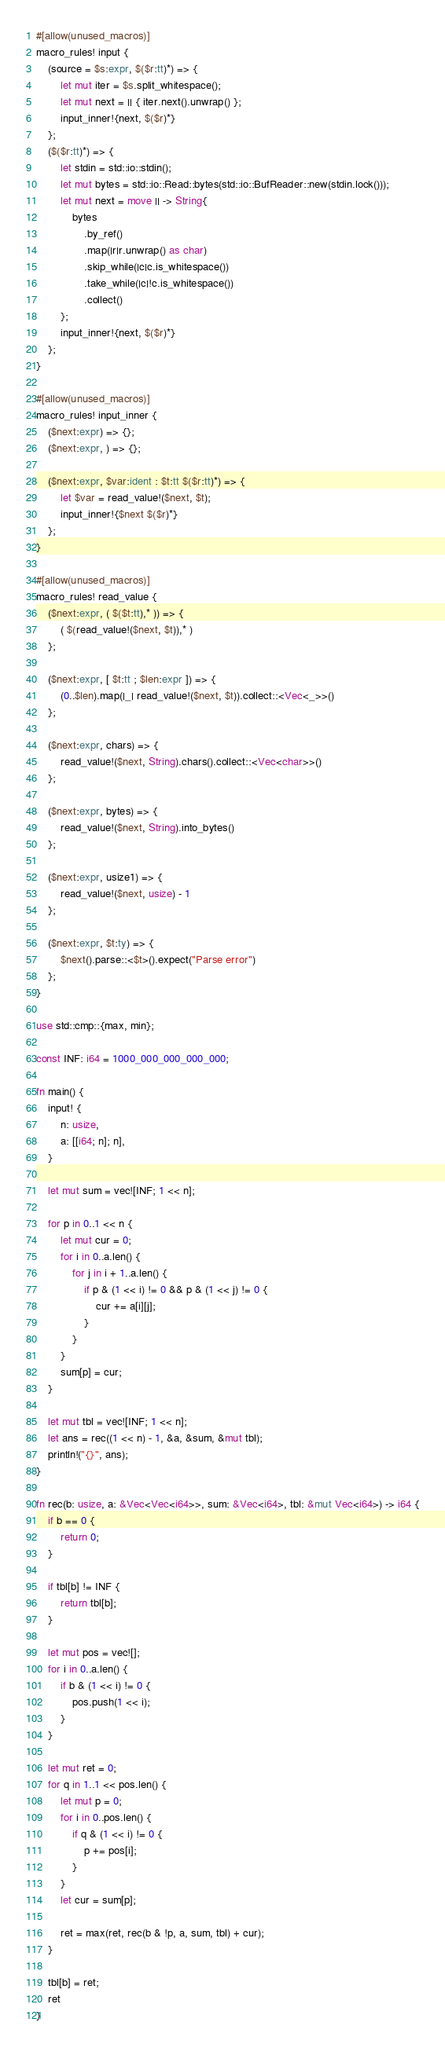<code> <loc_0><loc_0><loc_500><loc_500><_Rust_>#[allow(unused_macros)]
macro_rules! input {
    (source = $s:expr, $($r:tt)*) => {
        let mut iter = $s.split_whitespace();
        let mut next = || { iter.next().unwrap() };
        input_inner!{next, $($r)*}
    };
    ($($r:tt)*) => {
        let stdin = std::io::stdin();
        let mut bytes = std::io::Read::bytes(std::io::BufReader::new(stdin.lock()));
        let mut next = move || -> String{
            bytes
                .by_ref()
                .map(|r|r.unwrap() as char)
                .skip_while(|c|c.is_whitespace())
                .take_while(|c|!c.is_whitespace())
                .collect()
        };
        input_inner!{next, $($r)*}
    };
}

#[allow(unused_macros)]
macro_rules! input_inner {
    ($next:expr) => {};
    ($next:expr, ) => {};

    ($next:expr, $var:ident : $t:tt $($r:tt)*) => {
        let $var = read_value!($next, $t);
        input_inner!{$next $($r)*}
    };
}

#[allow(unused_macros)]
macro_rules! read_value {
    ($next:expr, ( $($t:tt),* )) => {
        ( $(read_value!($next, $t)),* )
    };

    ($next:expr, [ $t:tt ; $len:expr ]) => {
        (0..$len).map(|_| read_value!($next, $t)).collect::<Vec<_>>()
    };

    ($next:expr, chars) => {
        read_value!($next, String).chars().collect::<Vec<char>>()
    };

    ($next:expr, bytes) => {
        read_value!($next, String).into_bytes()
    };

    ($next:expr, usize1) => {
        read_value!($next, usize) - 1
    };

    ($next:expr, $t:ty) => {
        $next().parse::<$t>().expect("Parse error")
    };
}

use std::cmp::{max, min};

const INF: i64 = 1000_000_000_000_000;

fn main() {
    input! {
        n: usize,
        a: [[i64; n]; n],
    }

    let mut sum = vec![INF; 1 << n];

    for p in 0..1 << n {
        let mut cur = 0;
        for i in 0..a.len() {
            for j in i + 1..a.len() {
                if p & (1 << i) != 0 && p & (1 << j) != 0 {
                    cur += a[i][j];
                }
            }
        }
        sum[p] = cur;
    }

    let mut tbl = vec![INF; 1 << n];
    let ans = rec((1 << n) - 1, &a, &sum, &mut tbl);
    println!("{}", ans);
}

fn rec(b: usize, a: &Vec<Vec<i64>>, sum: &Vec<i64>, tbl: &mut Vec<i64>) -> i64 {
    if b == 0 {
        return 0;
    }

    if tbl[b] != INF {
        return tbl[b];
    }

    let mut pos = vec![];
    for i in 0..a.len() {
        if b & (1 << i) != 0 {
            pos.push(1 << i);
        }
    }

    let mut ret = 0;
    for q in 1..1 << pos.len() {
        let mut p = 0;
        for i in 0..pos.len() {
            if q & (1 << i) != 0 {
                p += pos[i];
            }
        }
        let cur = sum[p];

        ret = max(ret, rec(b & !p, a, sum, tbl) + cur);
    }

    tbl[b] = ret;
    ret
}
</code> 